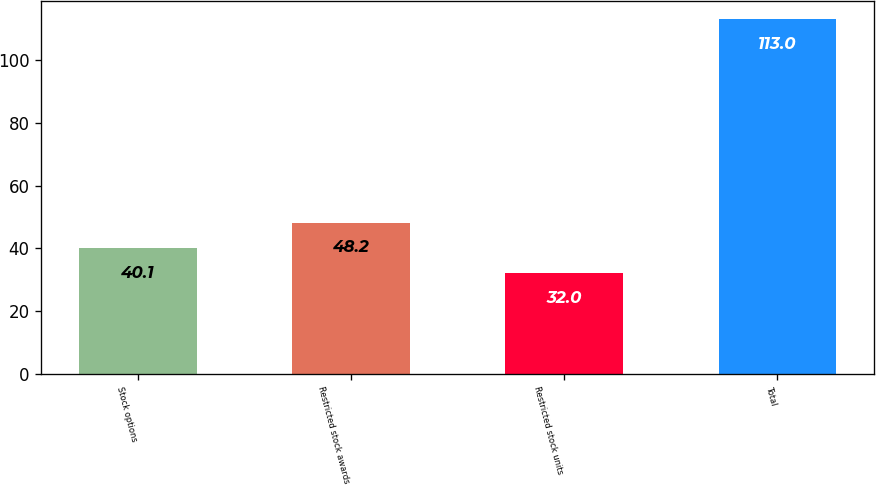<chart> <loc_0><loc_0><loc_500><loc_500><bar_chart><fcel>Stock options<fcel>Restricted stock awards<fcel>Restricted stock units<fcel>Total<nl><fcel>40.1<fcel>48.2<fcel>32<fcel>113<nl></chart> 